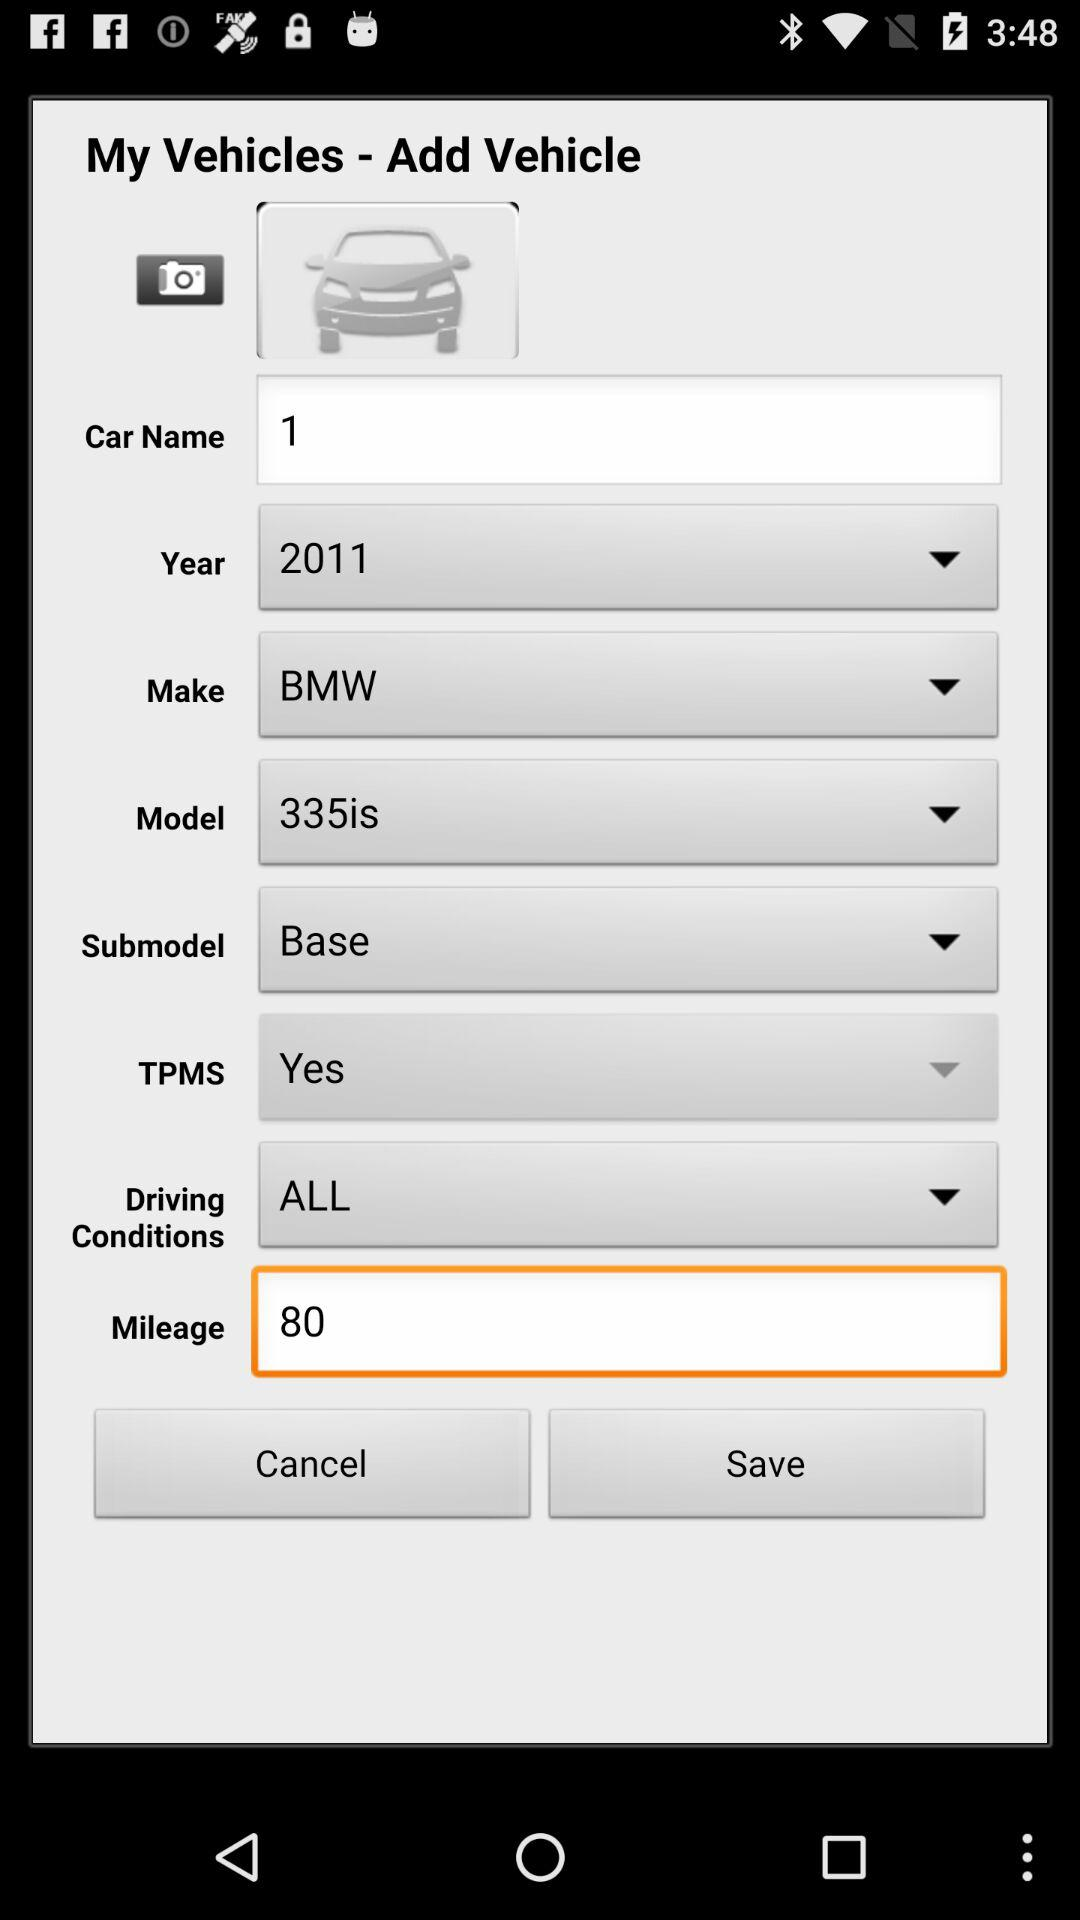What are the driving conditions selected? The driving condition selected is "ALL". 